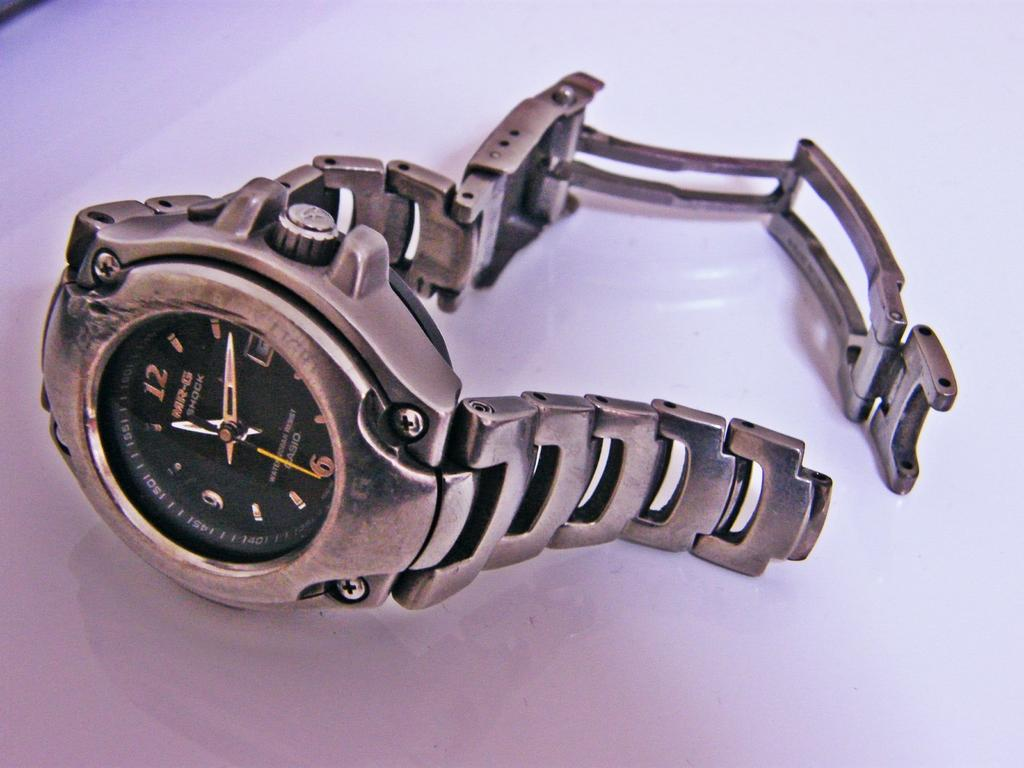<image>
Summarize the visual content of the image. The silver colored watch is from the company Casio 